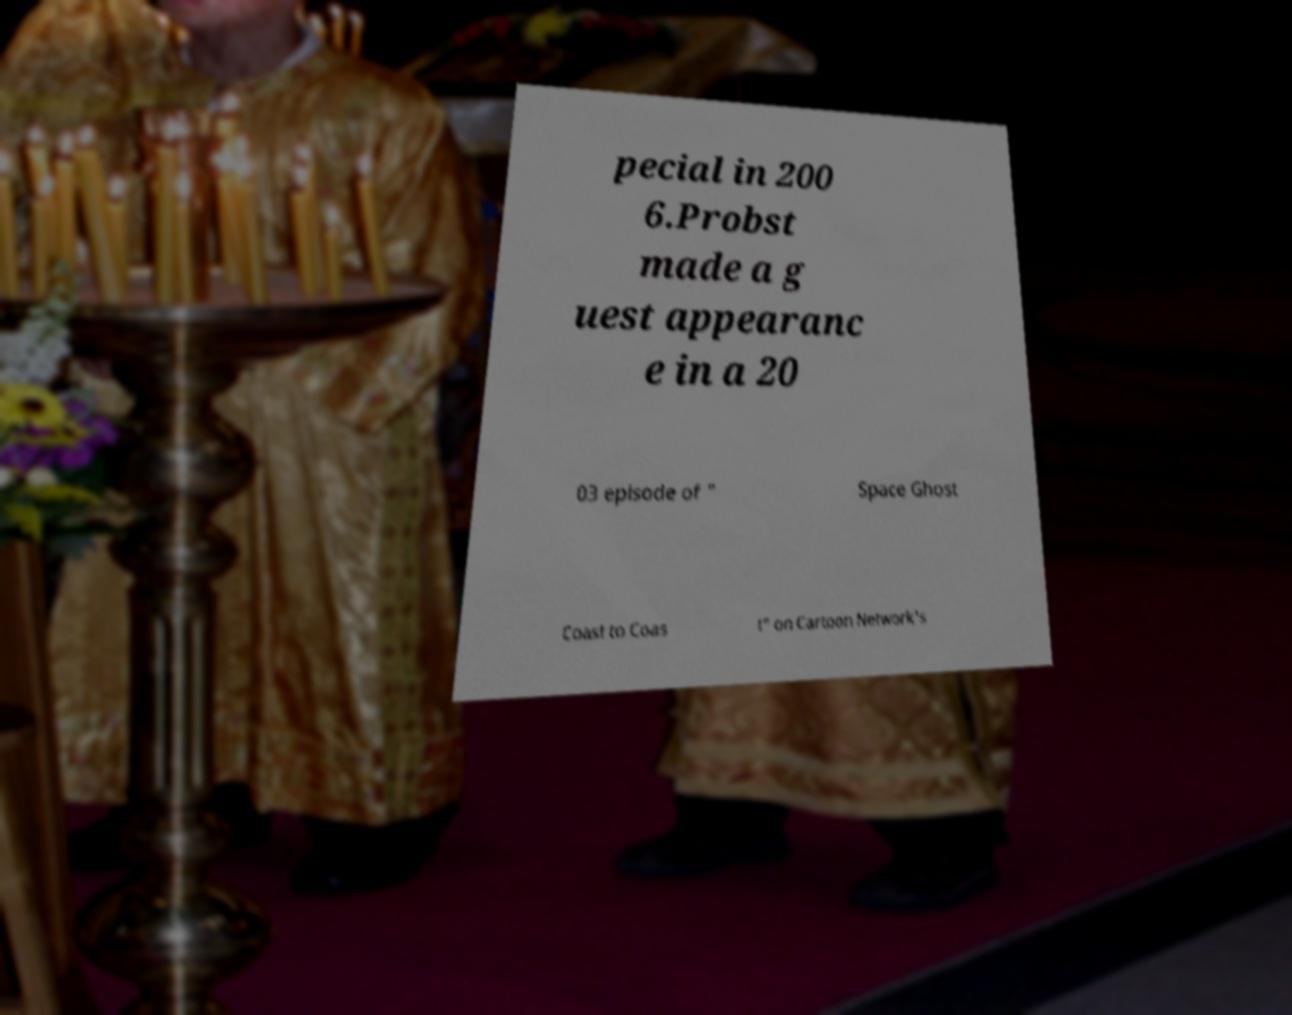I need the written content from this picture converted into text. Can you do that? pecial in 200 6.Probst made a g uest appearanc e in a 20 03 episode of " Space Ghost Coast to Coas t" on Cartoon Network's 